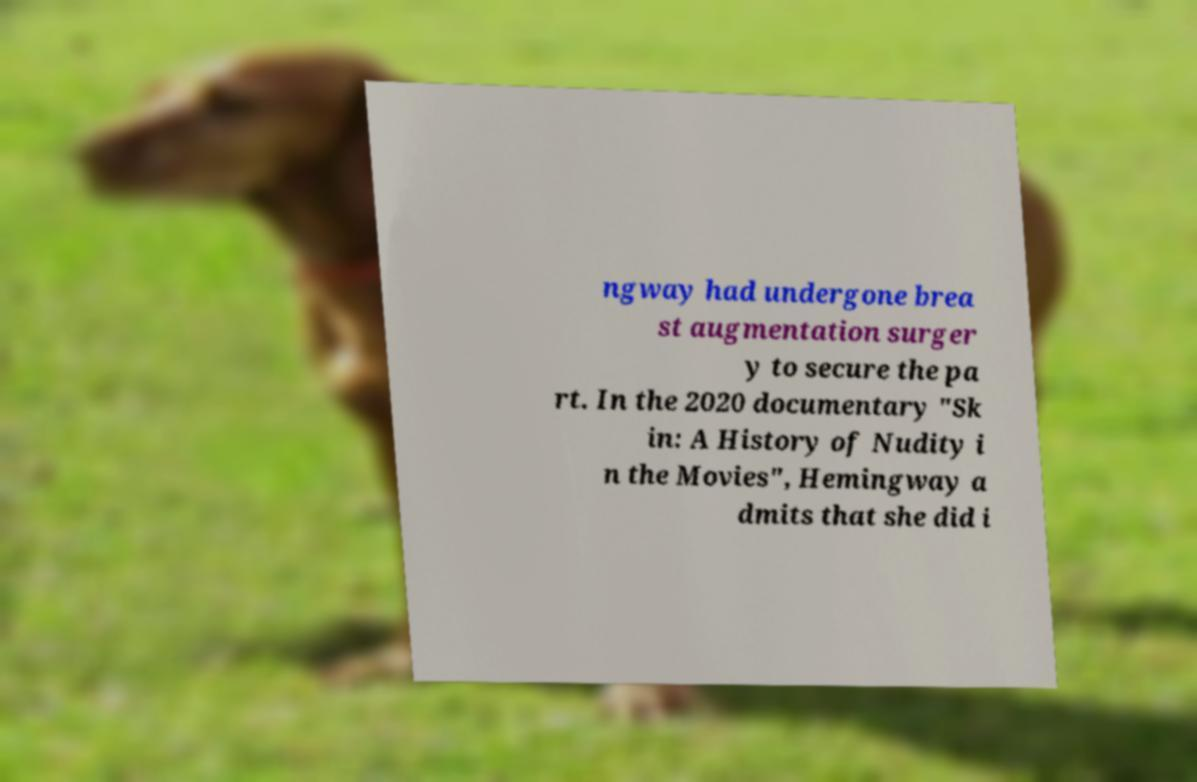Please identify and transcribe the text found in this image. ngway had undergone brea st augmentation surger y to secure the pa rt. In the 2020 documentary "Sk in: A History of Nudity i n the Movies", Hemingway a dmits that she did i 